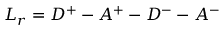<formula> <loc_0><loc_0><loc_500><loc_500>L _ { r } = D ^ { + } - A ^ { + } - D ^ { - } - A ^ { - }</formula> 